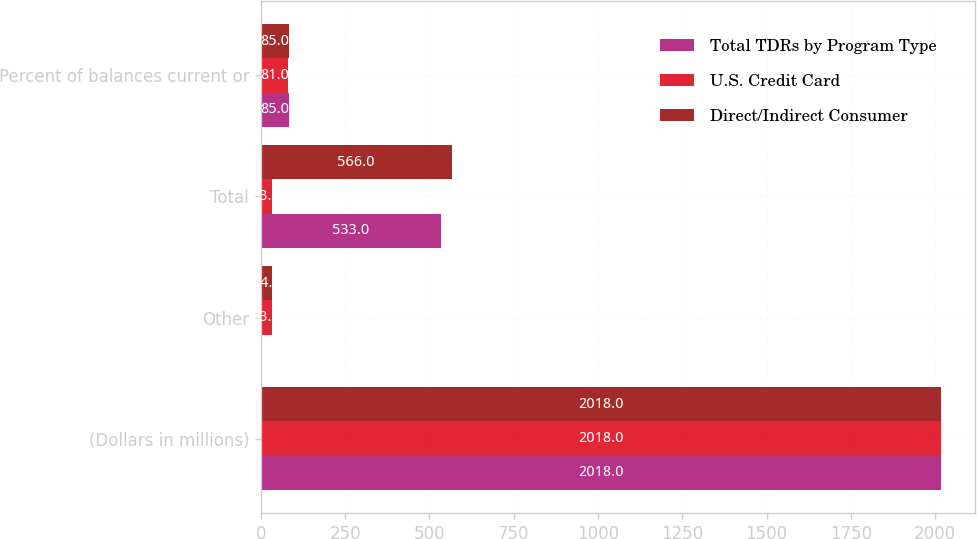Convert chart. <chart><loc_0><loc_0><loc_500><loc_500><stacked_bar_chart><ecel><fcel>(Dollars in millions)<fcel>Other<fcel>Total<fcel>Percent of balances current or<nl><fcel>Total TDRs by Program Type<fcel>2018<fcel>1<fcel>533<fcel>85<nl><fcel>U.S. Credit Card<fcel>2018<fcel>33<fcel>33<fcel>81<nl><fcel>Direct/Indirect Consumer<fcel>2018<fcel>34<fcel>566<fcel>85<nl></chart> 